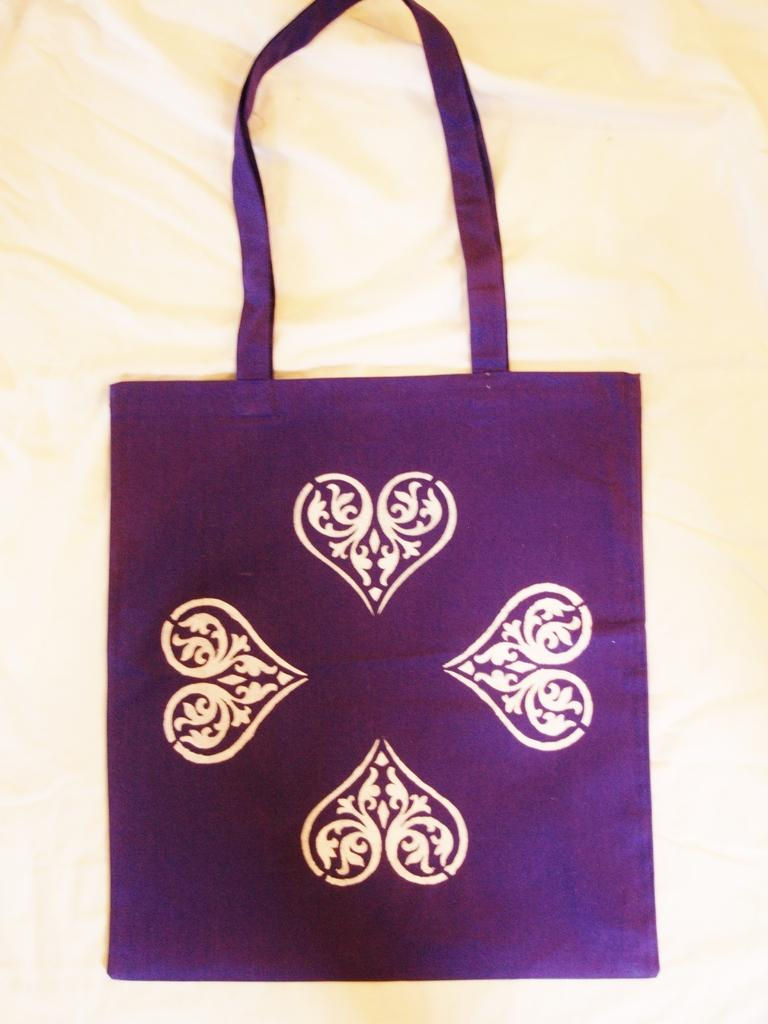What color is the bag in the image? The bag in the image is violet. Are there any patterns or designs on the bag? Yes, the bag has designs on it. How can the bag be carried? The bag has a handle for carrying. What is the bag placed on in the image? The bag is placed on a cloth. How much money is inside the bag in the image? There is no information about money or its contents in the image, so we cannot determine if there is any money inside the bag. 